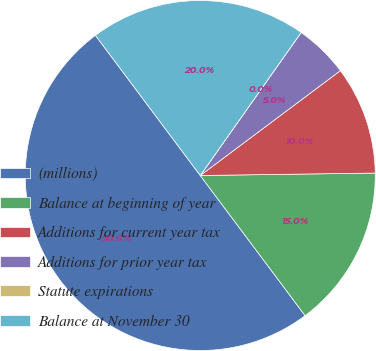Convert chart. <chart><loc_0><loc_0><loc_500><loc_500><pie_chart><fcel>(millions)<fcel>Balance at beginning of year<fcel>Additions for current year tax<fcel>Additions for prior year tax<fcel>Statute expirations<fcel>Balance at November 30<nl><fcel>50.0%<fcel>15.0%<fcel>10.0%<fcel>5.0%<fcel>0.0%<fcel>20.0%<nl></chart> 